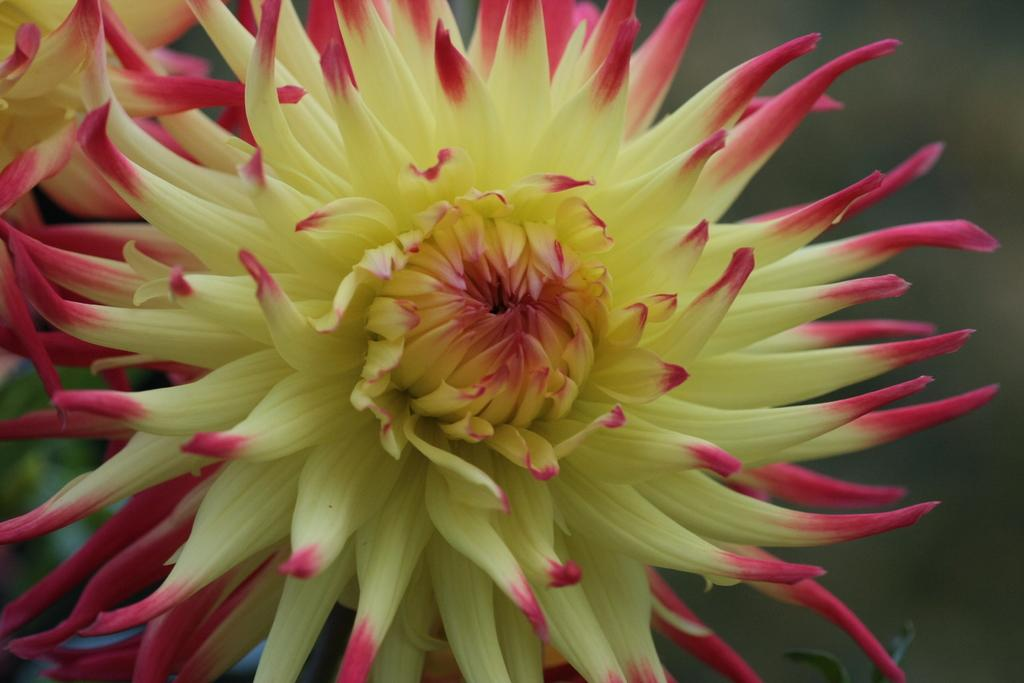What is the main subject of the image? There are flowers in the center of the image. What can be seen in the background of the image? There are green leaves and other objects visible in the background of the image. What type of agreement is being discussed by the flowers in the image? There is no indication in the image that the flowers are discussing any agreements, as they are inanimate objects. 